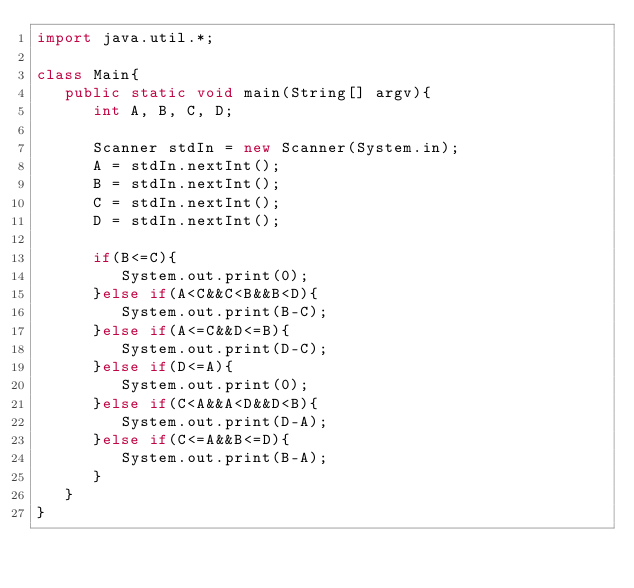<code> <loc_0><loc_0><loc_500><loc_500><_Java_>import java.util.*;

class Main{
   public static void main(String[] argv){
      int A, B, C, D;
      
      Scanner stdIn = new Scanner(System.in);
      A = stdIn.nextInt();
      B = stdIn.nextInt();
      C = stdIn.nextInt();
      D = stdIn.nextInt();
      
      if(B<=C){
         System.out.print(0);
      }else if(A<C&&C<B&&B<D){
         System.out.print(B-C);
      }else if(A<=C&&D<=B){
         System.out.print(D-C);
      }else if(D<=A){
         System.out.print(0);
      }else if(C<A&&A<D&&D<B){
         System.out.print(D-A);
      }else if(C<=A&&B<=D){
         System.out.print(B-A);
      }
   }
}</code> 